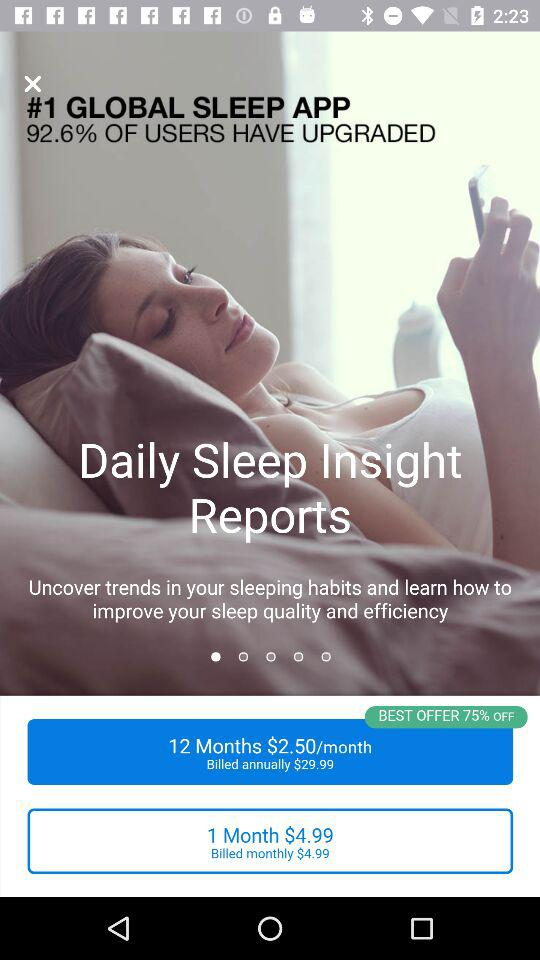What is the best offer percentage? The best offer percentage is 75. 